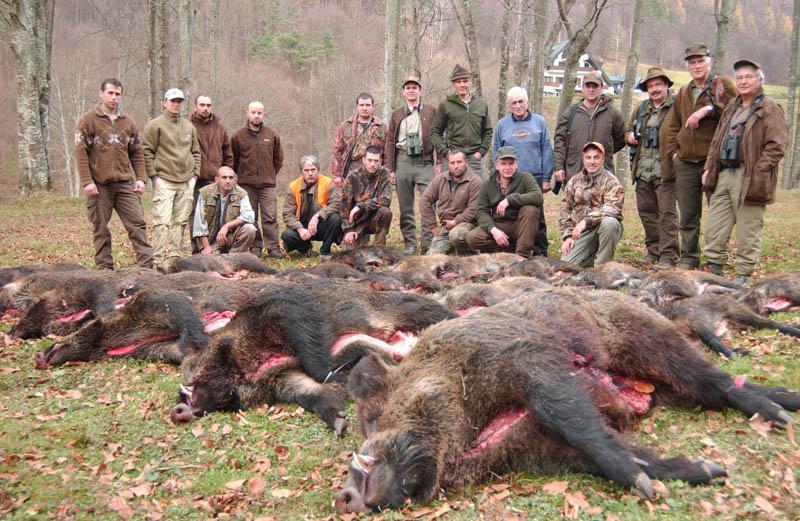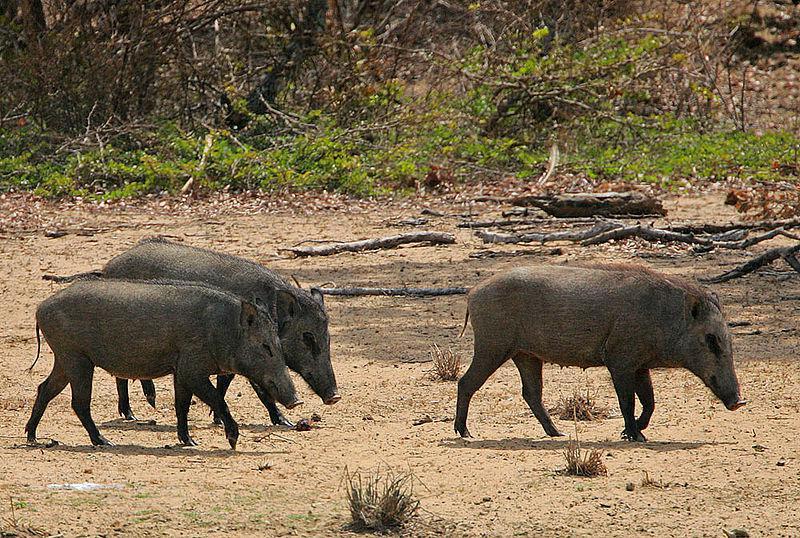The first image is the image on the left, the second image is the image on the right. Given the left and right images, does the statement "Contains one picture with three or less pigs." hold true? Answer yes or no. Yes. 